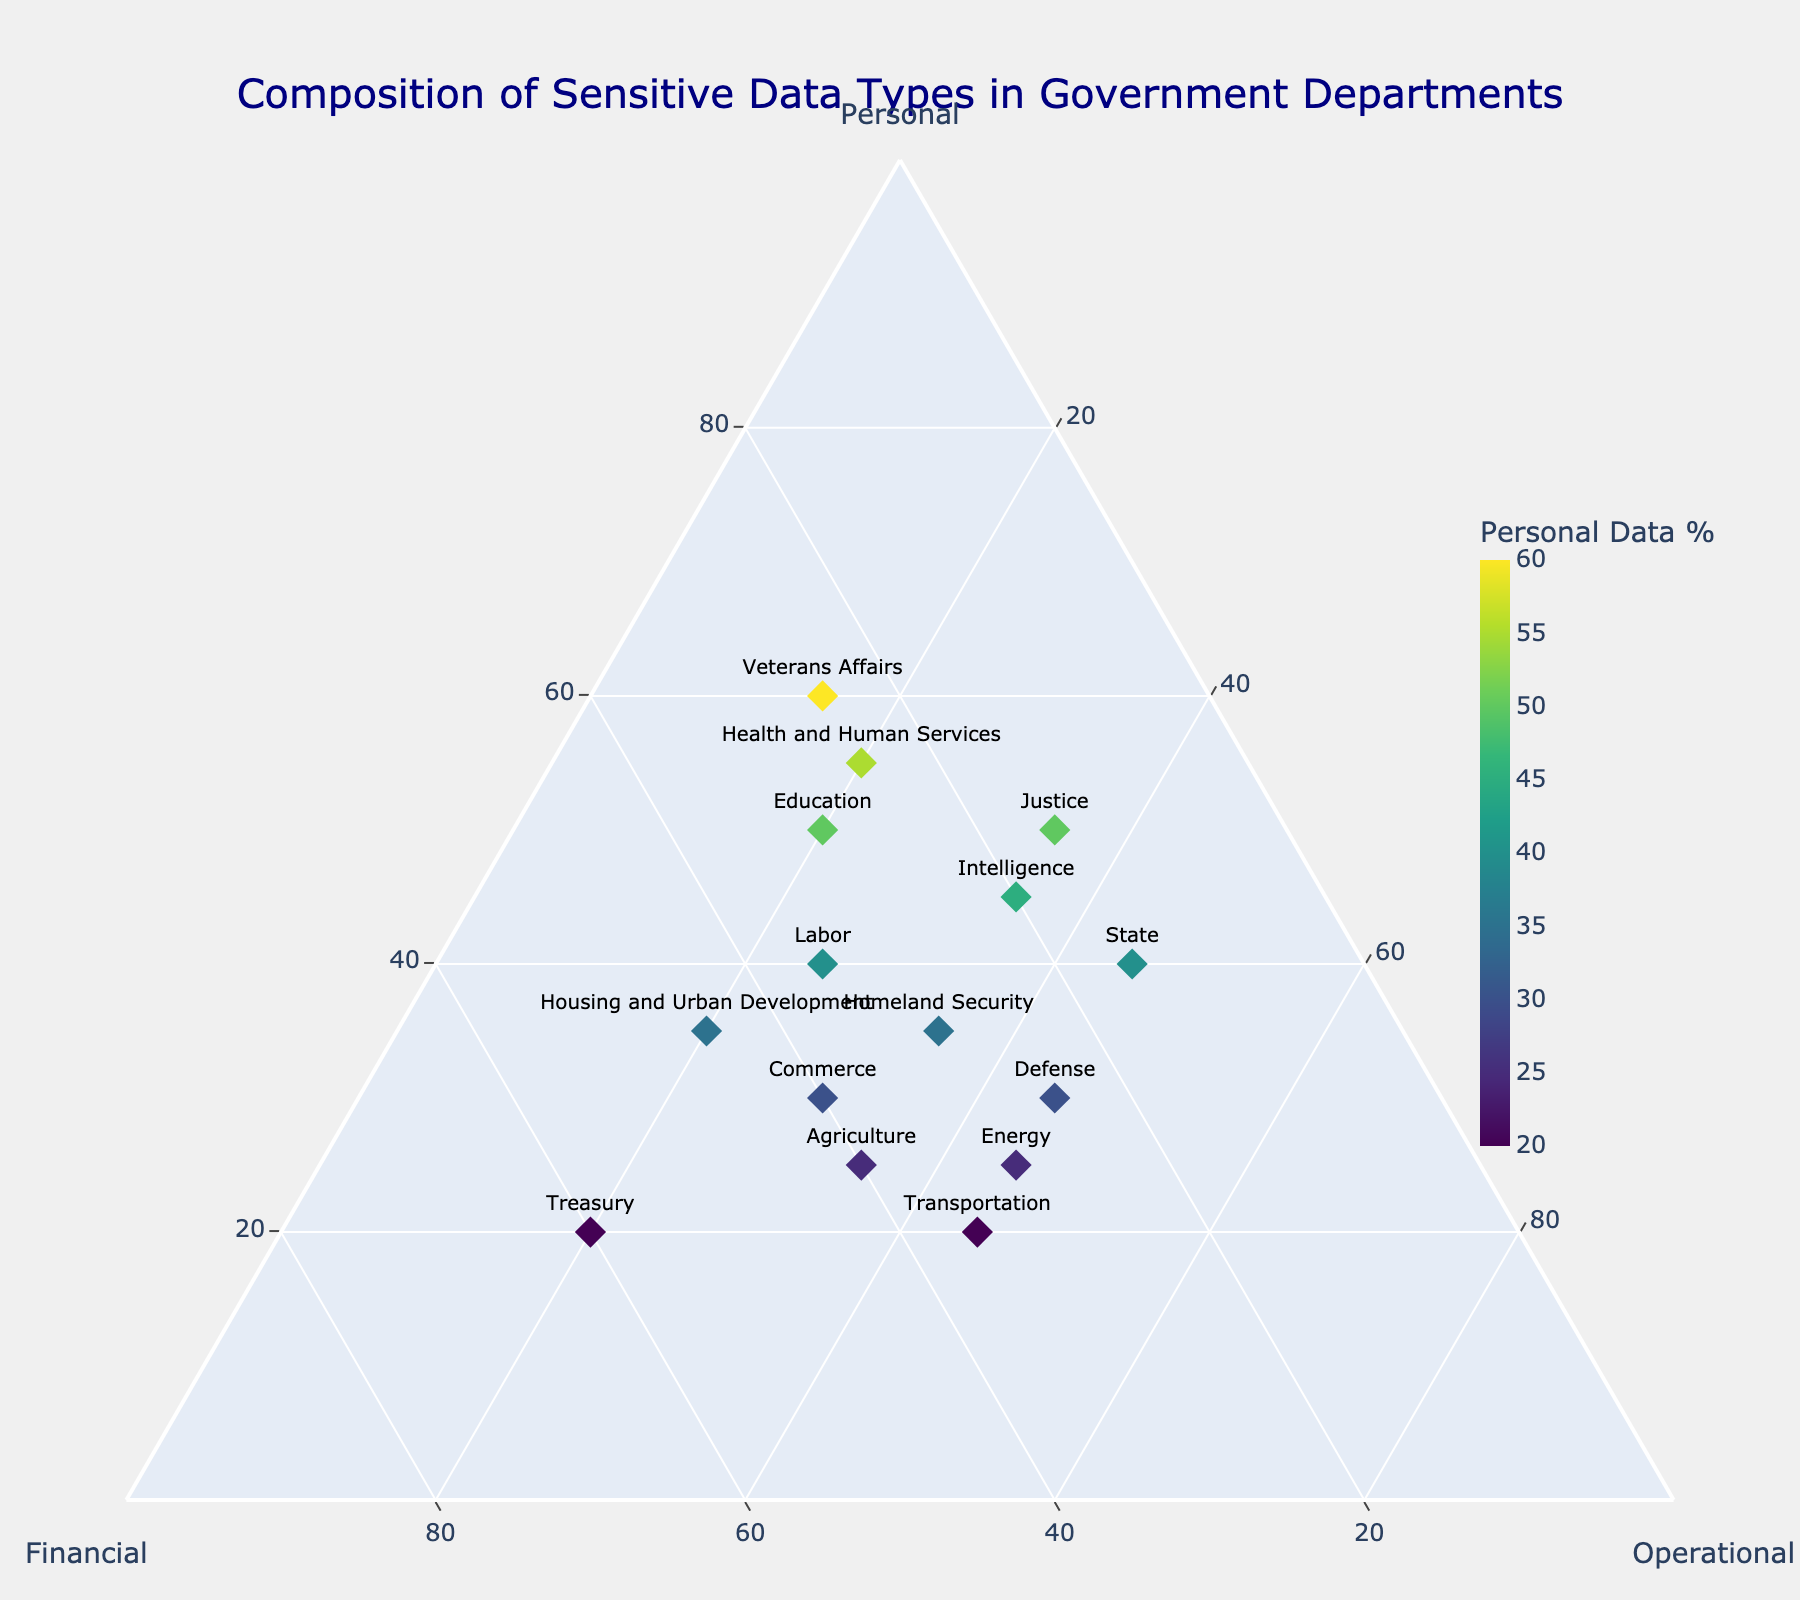What's the title of the plot? The title of the plot is displayed prominently at the top center. It reads "Composition of Sensitive Data Types in Government Departments".
Answer: Composition of Sensitive Data Types in Government Departments How many departments have more than 50% personal data? To answer this, look for departments plotted towards the "Personal" side of the ternary diagram, specifically for values above 50. These departments are "Health and Human Services" and "Veterans Affairs".
Answer: 2 Which department has the highest percentage of financial data? Check the financial axis to find the department plotted farthest along this line. The "Treasury" department is at 60% financial data.
Answer: Treasury What is the composition of sensitive data for the Department of Defense? Identify the data point labeled "Defense" on the ternary plot. This department has 30% personal, 25% financial, and 45% operational data.
Answer: 30% Personal, 25% Financial, 45% Operational Which department has the lowest percentage of operational data? Check the operational axis to find the department plotted more towards the center away from the operational data line. The "Veterans Affairs" department has the lowest at 15%.
Answer: Veterans Affairs Which departments have an equal percentage of personal and operational data? Identify points where personal and operational percentages are the same. Both "Intelligence" and "State" departments have 35% operational data and close percentages for personal data, but exact percentages need verification from the plot.
Answer: None Are there any departments with exactly 40% personal and operational data? Review the plot to locate departments plotted near the 40% markers for both the personal and operational axes. The "Labor" department has exactly 40% personal but only 25% operational, so no department matches both criteria.
Answer: No What is the median percentage of personal data among all departments? List the percentages of personal data, then find the median by arranging them in ascending order: 20, 20, 20, 25, 25, 30, 30, 30, 35, 35, 40, 40, 45, 50, 55, 60. The middle value (median) is between 35 and 40.
Answer: 37.5% How many departments have higher operational data than personal data? For each department, compare percentages of operational and personal data. They are "Defense", "State", "Energy", and "Transportation".
Answer: 4 Which department lies closest to an equal split among all three data types? Check for a department plotted nearest the center of the ternary diagram. The "Homeland Security" department shows 35% personal, 30% financial, and 35% operational, which is fairly balanced.
Answer: Homeland Security 